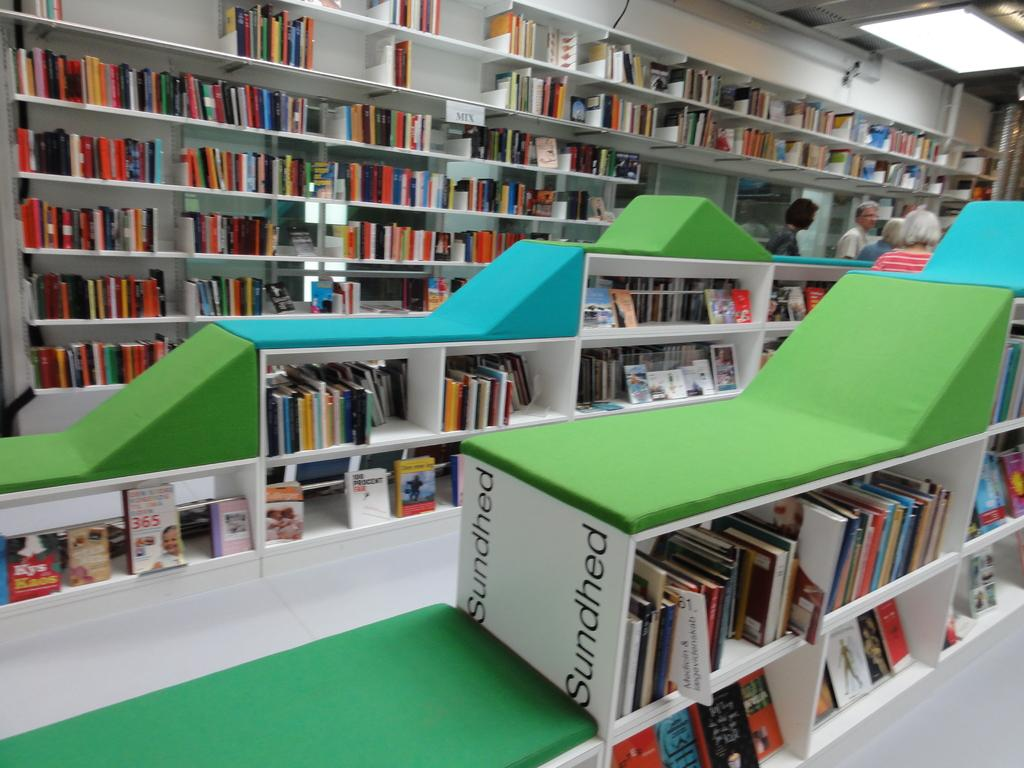Provide a one-sentence caption for the provided image. a white item with the word sundhed on it. 